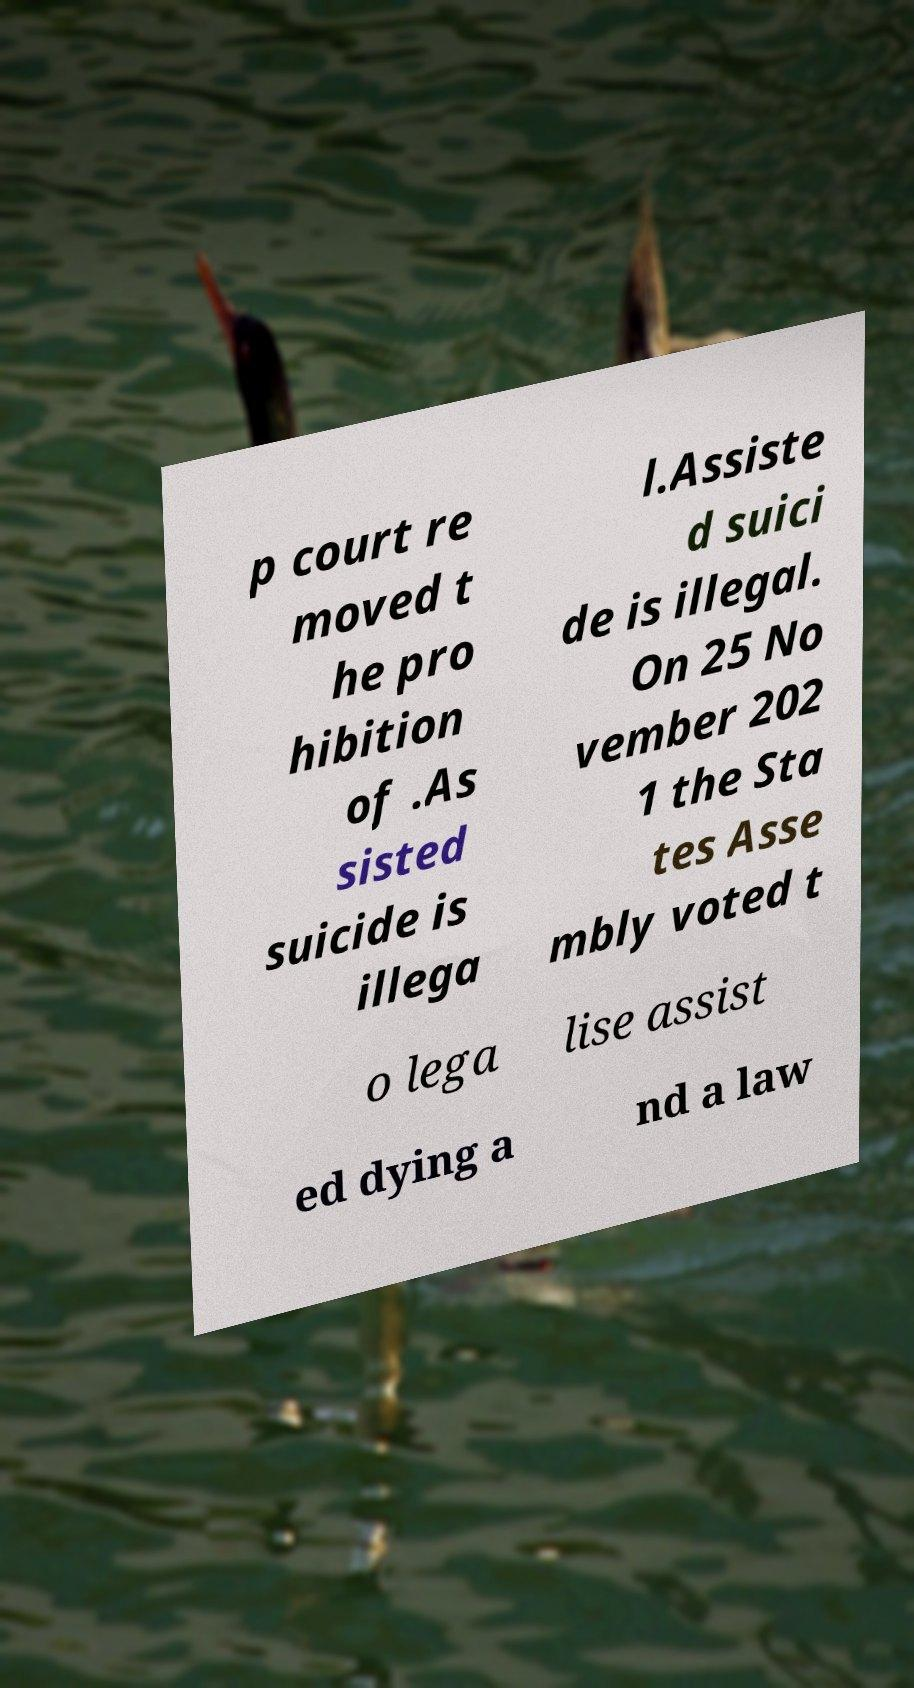Can you accurately transcribe the text from the provided image for me? p court re moved t he pro hibition of .As sisted suicide is illega l.Assiste d suici de is illegal. On 25 No vember 202 1 the Sta tes Asse mbly voted t o lega lise assist ed dying a nd a law 